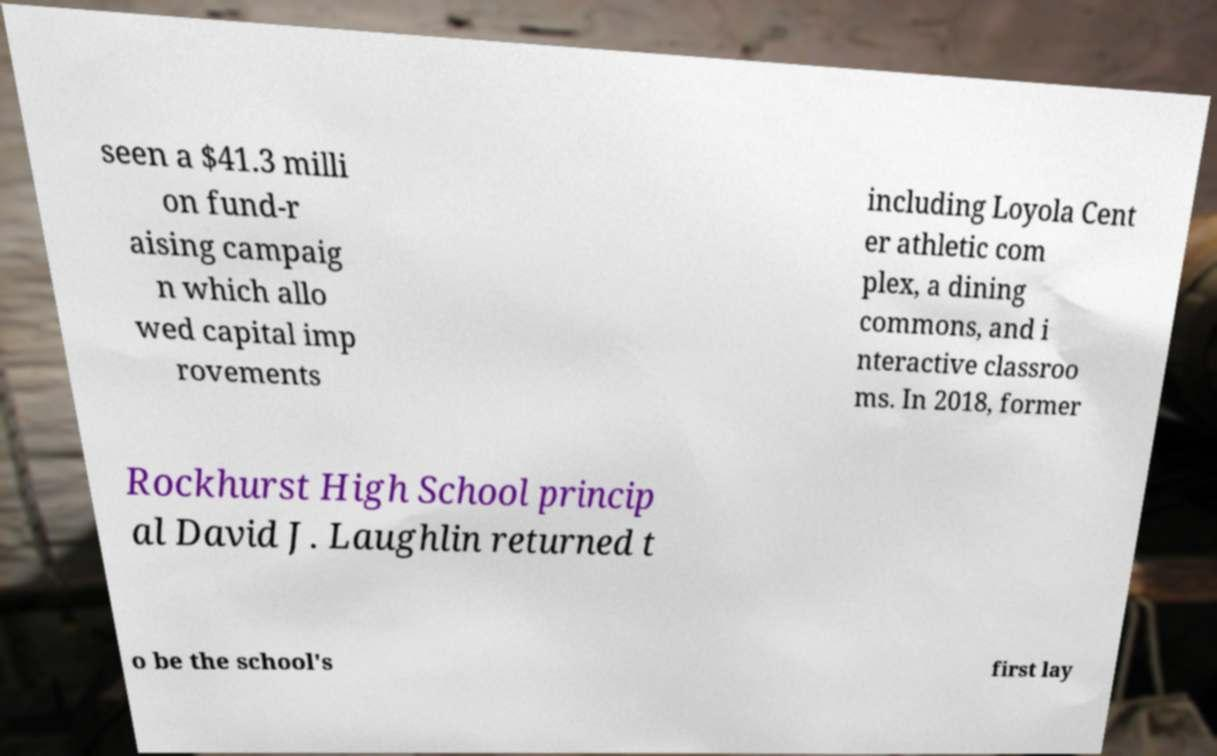Please identify and transcribe the text found in this image. seen a $41.3 milli on fund-r aising campaig n which allo wed capital imp rovements including Loyola Cent er athletic com plex, a dining commons, and i nteractive classroo ms. In 2018, former Rockhurst High School princip al David J. Laughlin returned t o be the school's first lay 